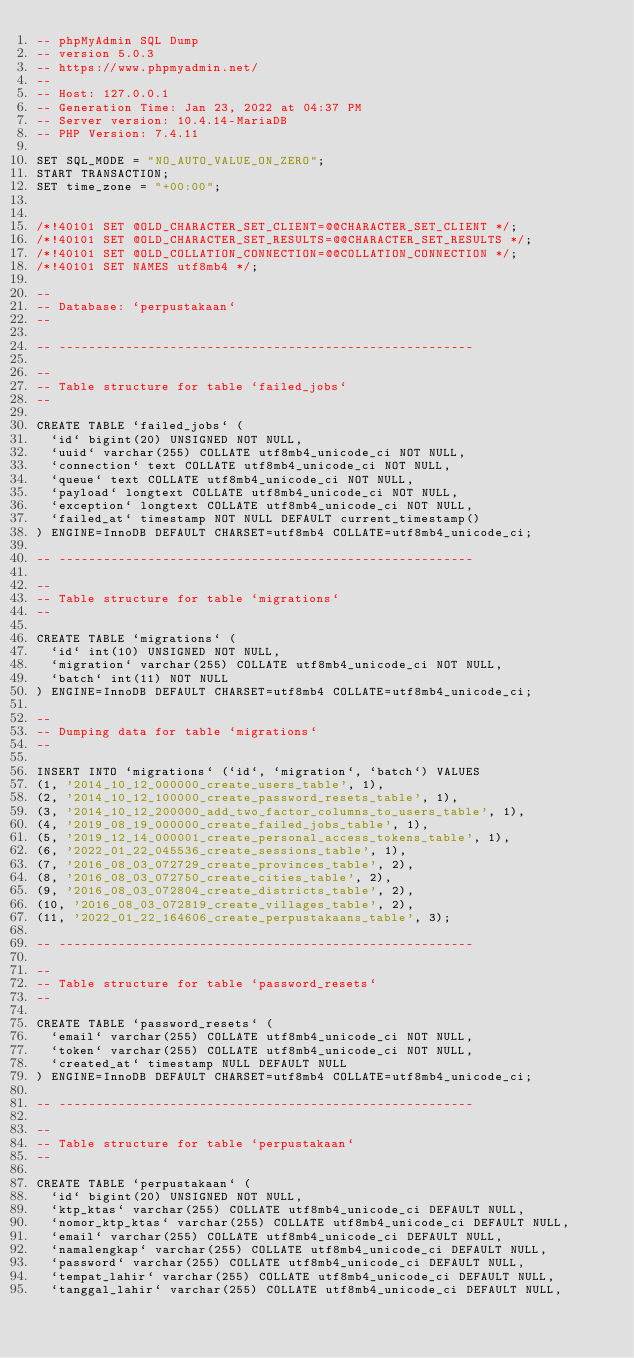Convert code to text. <code><loc_0><loc_0><loc_500><loc_500><_SQL_>-- phpMyAdmin SQL Dump
-- version 5.0.3
-- https://www.phpmyadmin.net/
--
-- Host: 127.0.0.1
-- Generation Time: Jan 23, 2022 at 04:37 PM
-- Server version: 10.4.14-MariaDB
-- PHP Version: 7.4.11

SET SQL_MODE = "NO_AUTO_VALUE_ON_ZERO";
START TRANSACTION;
SET time_zone = "+00:00";


/*!40101 SET @OLD_CHARACTER_SET_CLIENT=@@CHARACTER_SET_CLIENT */;
/*!40101 SET @OLD_CHARACTER_SET_RESULTS=@@CHARACTER_SET_RESULTS */;
/*!40101 SET @OLD_COLLATION_CONNECTION=@@COLLATION_CONNECTION */;
/*!40101 SET NAMES utf8mb4 */;

--
-- Database: `perpustakaan`
--

-- --------------------------------------------------------

--
-- Table structure for table `failed_jobs`
--

CREATE TABLE `failed_jobs` (
  `id` bigint(20) UNSIGNED NOT NULL,
  `uuid` varchar(255) COLLATE utf8mb4_unicode_ci NOT NULL,
  `connection` text COLLATE utf8mb4_unicode_ci NOT NULL,
  `queue` text COLLATE utf8mb4_unicode_ci NOT NULL,
  `payload` longtext COLLATE utf8mb4_unicode_ci NOT NULL,
  `exception` longtext COLLATE utf8mb4_unicode_ci NOT NULL,
  `failed_at` timestamp NOT NULL DEFAULT current_timestamp()
) ENGINE=InnoDB DEFAULT CHARSET=utf8mb4 COLLATE=utf8mb4_unicode_ci;

-- --------------------------------------------------------

--
-- Table structure for table `migrations`
--

CREATE TABLE `migrations` (
  `id` int(10) UNSIGNED NOT NULL,
  `migration` varchar(255) COLLATE utf8mb4_unicode_ci NOT NULL,
  `batch` int(11) NOT NULL
) ENGINE=InnoDB DEFAULT CHARSET=utf8mb4 COLLATE=utf8mb4_unicode_ci;

--
-- Dumping data for table `migrations`
--

INSERT INTO `migrations` (`id`, `migration`, `batch`) VALUES
(1, '2014_10_12_000000_create_users_table', 1),
(2, '2014_10_12_100000_create_password_resets_table', 1),
(3, '2014_10_12_200000_add_two_factor_columns_to_users_table', 1),
(4, '2019_08_19_000000_create_failed_jobs_table', 1),
(5, '2019_12_14_000001_create_personal_access_tokens_table', 1),
(6, '2022_01_22_045536_create_sessions_table', 1),
(7, '2016_08_03_072729_create_provinces_table', 2),
(8, '2016_08_03_072750_create_cities_table', 2),
(9, '2016_08_03_072804_create_districts_table', 2),
(10, '2016_08_03_072819_create_villages_table', 2),
(11, '2022_01_22_164606_create_perpustakaans_table', 3);

-- --------------------------------------------------------

--
-- Table structure for table `password_resets`
--

CREATE TABLE `password_resets` (
  `email` varchar(255) COLLATE utf8mb4_unicode_ci NOT NULL,
  `token` varchar(255) COLLATE utf8mb4_unicode_ci NOT NULL,
  `created_at` timestamp NULL DEFAULT NULL
) ENGINE=InnoDB DEFAULT CHARSET=utf8mb4 COLLATE=utf8mb4_unicode_ci;

-- --------------------------------------------------------

--
-- Table structure for table `perpustakaan`
--

CREATE TABLE `perpustakaan` (
  `id` bigint(20) UNSIGNED NOT NULL,
  `ktp_ktas` varchar(255) COLLATE utf8mb4_unicode_ci DEFAULT NULL,
  `nomor_ktp_ktas` varchar(255) COLLATE utf8mb4_unicode_ci DEFAULT NULL,
  `email` varchar(255) COLLATE utf8mb4_unicode_ci DEFAULT NULL,
  `namalengkap` varchar(255) COLLATE utf8mb4_unicode_ci DEFAULT NULL,
  `password` varchar(255) COLLATE utf8mb4_unicode_ci DEFAULT NULL,
  `tempat_lahir` varchar(255) COLLATE utf8mb4_unicode_ci DEFAULT NULL,
  `tanggal_lahir` varchar(255) COLLATE utf8mb4_unicode_ci DEFAULT NULL,</code> 